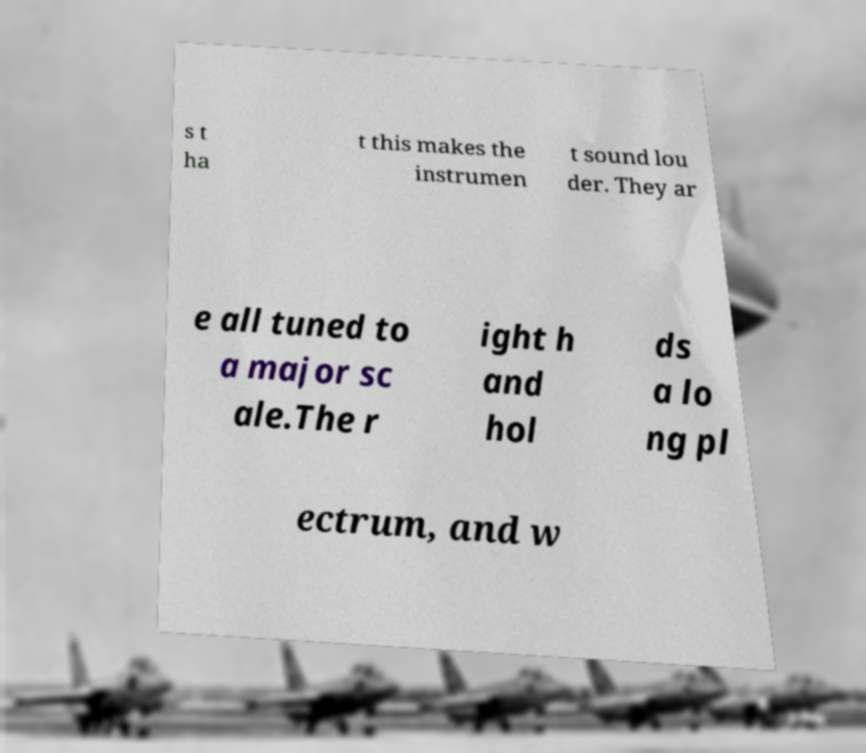Could you assist in decoding the text presented in this image and type it out clearly? s t ha t this makes the instrumen t sound lou der. They ar e all tuned to a major sc ale.The r ight h and hol ds a lo ng pl ectrum, and w 